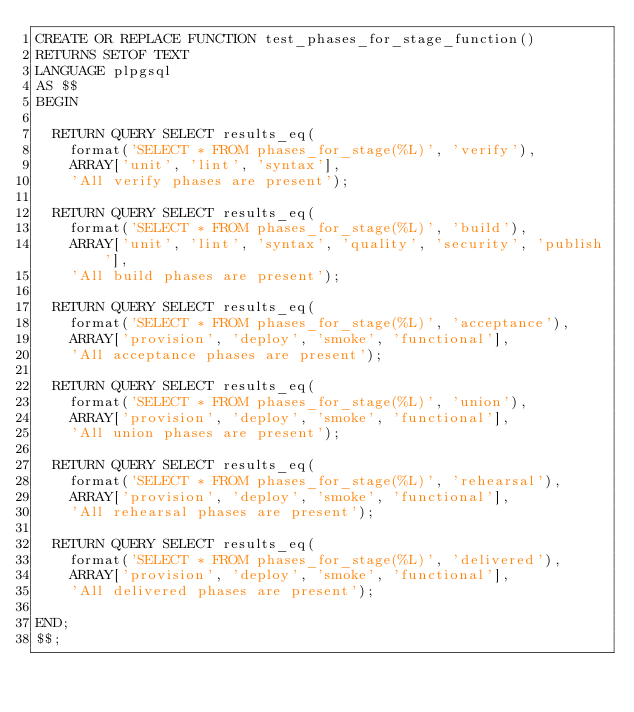Convert code to text. <code><loc_0><loc_0><loc_500><loc_500><_SQL_>CREATE OR REPLACE FUNCTION test_phases_for_stage_function()
RETURNS SETOF TEXT
LANGUAGE plpgsql
AS $$
BEGIN

  RETURN QUERY SELECT results_eq(
    format('SELECT * FROM phases_for_stage(%L)', 'verify'),
    ARRAY['unit', 'lint', 'syntax'],
    'All verify phases are present');

  RETURN QUERY SELECT results_eq(
    format('SELECT * FROM phases_for_stage(%L)', 'build'),
    ARRAY['unit', 'lint', 'syntax', 'quality', 'security', 'publish'],
    'All build phases are present');

  RETURN QUERY SELECT results_eq(
    format('SELECT * FROM phases_for_stage(%L)', 'acceptance'),
    ARRAY['provision', 'deploy', 'smoke', 'functional'],
    'All acceptance phases are present');

  RETURN QUERY SELECT results_eq(
    format('SELECT * FROM phases_for_stage(%L)', 'union'),
    ARRAY['provision', 'deploy', 'smoke', 'functional'],
    'All union phases are present');

  RETURN QUERY SELECT results_eq(
    format('SELECT * FROM phases_for_stage(%L)', 'rehearsal'),
    ARRAY['provision', 'deploy', 'smoke', 'functional'],
    'All rehearsal phases are present');

  RETURN QUERY SELECT results_eq(
    format('SELECT * FROM phases_for_stage(%L)', 'delivered'),
    ARRAY['provision', 'deploy', 'smoke', 'functional'],
    'All delivered phases are present');

END;
$$;
</code> 